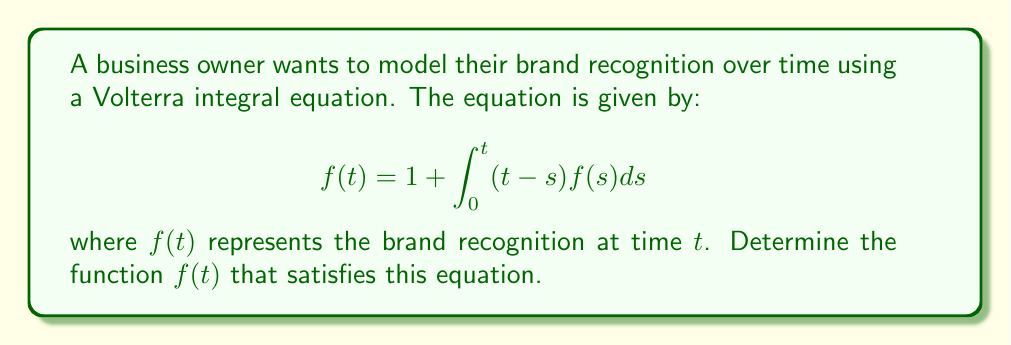What is the answer to this math problem? To solve this Volterra integral equation, we'll use the following steps:

1) First, let's differentiate both sides of the equation with respect to $t$:

   $$f'(t) = \frac{d}{dt}\left(1 + \int_0^t (t-s)f(s)ds\right)$$

2) Using Leibniz's rule for differentiating an integral:

   $$f'(t) = 0 + \int_0^t f(s)ds + (t-t)f(t) = \int_0^t f(s)ds$$

3) Differentiate again:

   $$f''(t) = \frac{d}{dt}\int_0^t f(s)ds = f(t)$$

4) We now have a second-order differential equation: $f''(t) = f(t)$

5) The general solution to this equation is:

   $$f(t) = Ae^t + Be^{-t}$$

   where $A$ and $B$ are constants to be determined.

6) To find $A$ and $B$, we use the initial conditions:
   - From the original equation, $f(0) = 1$
   - From step 2, $f'(0) = 0$

7) Applying these conditions:
   - $f(0) = A + B = 1$
   - $f'(0) = A - B = 0$

8) Solving these simultaneous equations:
   $A = B = \frac{1}{2}$

9) Therefore, the final solution is:

   $$f(t) = \frac{1}{2}(e^t + e^{-t}) = \cosh(t)$$

This function represents how brand recognition grows over time, starting at 1 and increasing exponentially, which aligns with the business owner's goal of leaving a lasting impression on users.
Answer: $f(t) = \cosh(t)$ 